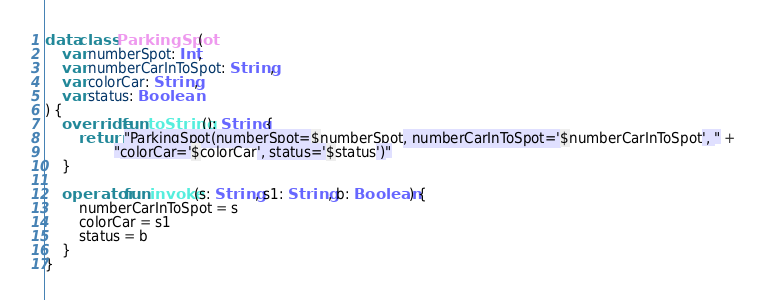<code> <loc_0><loc_0><loc_500><loc_500><_Kotlin_>data class ParkingSpot(
    var numberSpot: Int,
    var numberCarInToSpot: String,
    var colorCar: String,
    var status: Boolean
) {
    override fun toString(): String {
        return "ParkingSpot(numberSpot=$numberSpot, numberCarInToSpot='$numberCarInToSpot', " +
                "colorCar='$colorCar', status='$status')"
    }

    operator fun invoke(s: String, s1: String, b: Boolean) {
        numberCarInToSpot = s
        colorCar = s1
        status = b
    }
}
</code> 